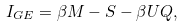Convert formula to latex. <formula><loc_0><loc_0><loc_500><loc_500>I _ { G E } = \beta M - S - \beta U Q ,</formula> 